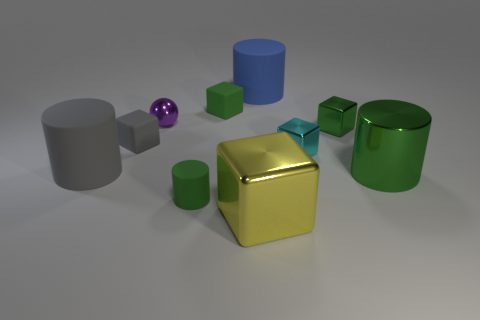Subtract all gray cubes. How many cubes are left? 4 Subtract all yellow metallic cubes. How many cubes are left? 4 Subtract 1 cylinders. How many cylinders are left? 3 Subtract all purple cubes. Subtract all yellow cylinders. How many cubes are left? 5 Subtract all balls. How many objects are left? 9 Add 9 tiny gray things. How many tiny gray things exist? 10 Subtract 0 brown cubes. How many objects are left? 10 Subtract all metallic objects. Subtract all tiny rubber things. How many objects are left? 2 Add 8 yellow shiny cubes. How many yellow shiny cubes are left? 9 